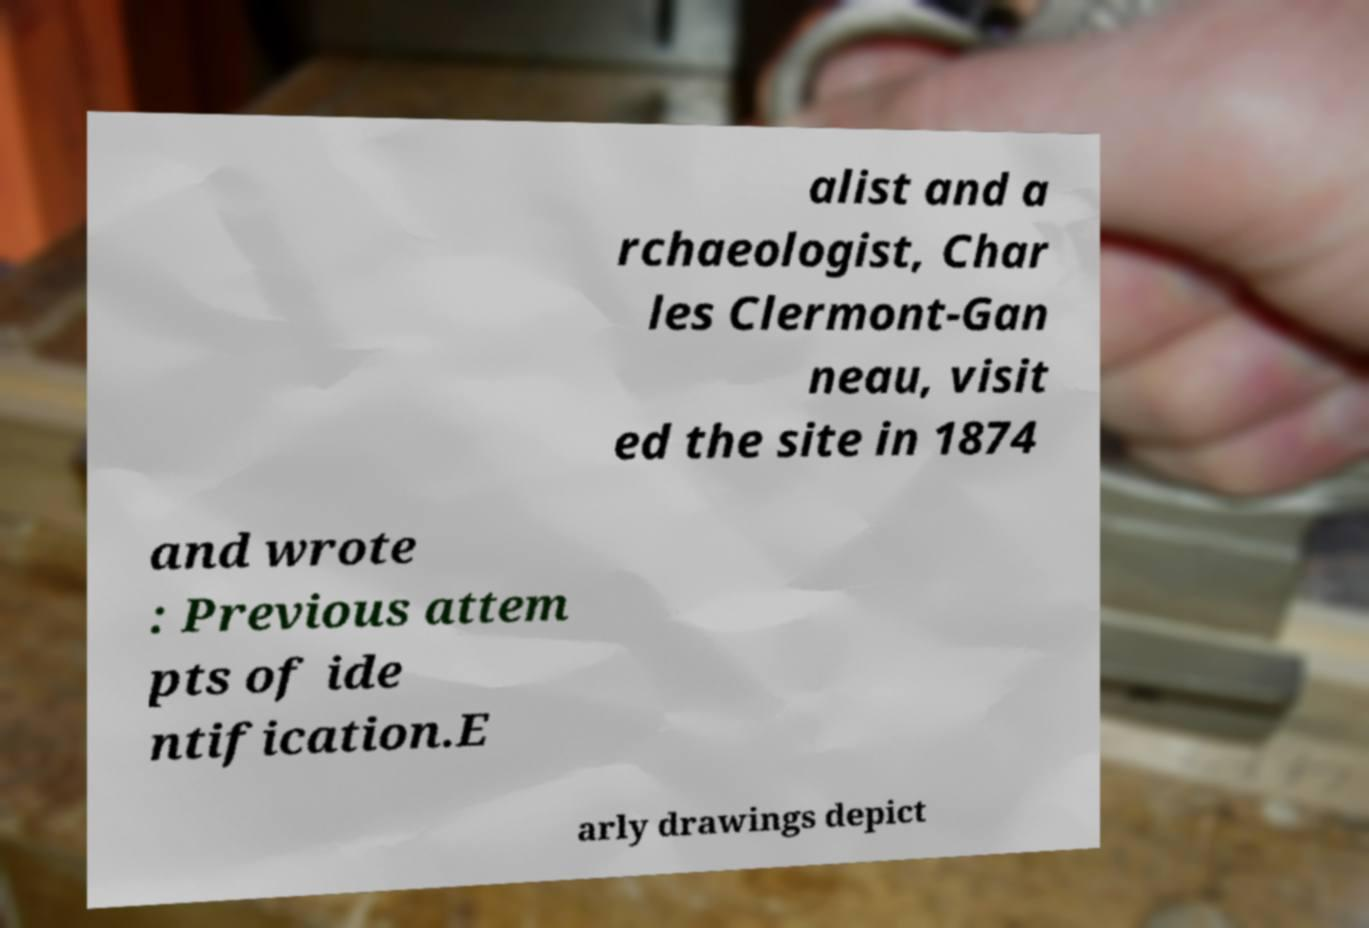Please identify and transcribe the text found in this image. alist and a rchaeologist, Char les Clermont-Gan neau, visit ed the site in 1874 and wrote : Previous attem pts of ide ntification.E arly drawings depict 